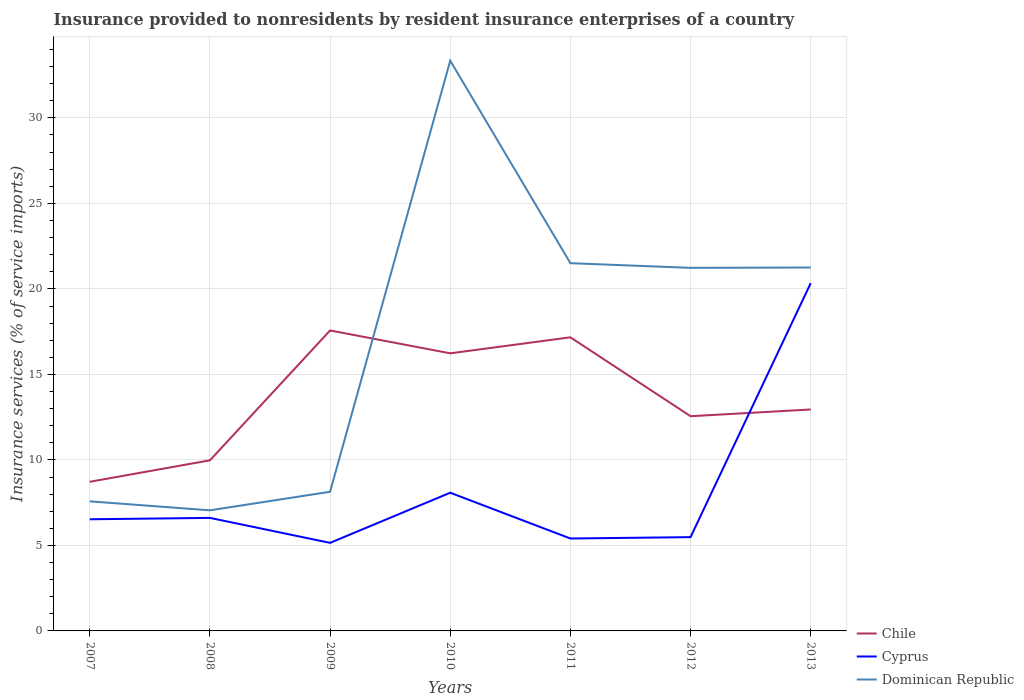How many different coloured lines are there?
Provide a short and direct response. 3. Does the line corresponding to Chile intersect with the line corresponding to Cyprus?
Ensure brevity in your answer.  Yes. Is the number of lines equal to the number of legend labels?
Offer a very short reply. Yes. Across all years, what is the maximum insurance provided to nonresidents in Dominican Republic?
Make the answer very short. 7.05. In which year was the insurance provided to nonresidents in Chile maximum?
Keep it short and to the point. 2007. What is the total insurance provided to nonresidents in Chile in the graph?
Ensure brevity in your answer.  -1.25. What is the difference between the highest and the second highest insurance provided to nonresidents in Chile?
Your answer should be compact. 8.85. Is the insurance provided to nonresidents in Chile strictly greater than the insurance provided to nonresidents in Cyprus over the years?
Provide a succinct answer. No. How many lines are there?
Make the answer very short. 3. Does the graph contain any zero values?
Provide a short and direct response. No. Does the graph contain grids?
Make the answer very short. Yes. What is the title of the graph?
Your response must be concise. Insurance provided to nonresidents by resident insurance enterprises of a country. Does "Burkina Faso" appear as one of the legend labels in the graph?
Ensure brevity in your answer.  No. What is the label or title of the Y-axis?
Give a very brief answer. Insurance services (% of service imports). What is the Insurance services (% of service imports) in Chile in 2007?
Give a very brief answer. 8.72. What is the Insurance services (% of service imports) in Cyprus in 2007?
Your answer should be compact. 6.53. What is the Insurance services (% of service imports) of Dominican Republic in 2007?
Ensure brevity in your answer.  7.58. What is the Insurance services (% of service imports) of Chile in 2008?
Provide a succinct answer. 9.98. What is the Insurance services (% of service imports) of Cyprus in 2008?
Provide a short and direct response. 6.61. What is the Insurance services (% of service imports) of Dominican Republic in 2008?
Make the answer very short. 7.05. What is the Insurance services (% of service imports) in Chile in 2009?
Your response must be concise. 17.57. What is the Insurance services (% of service imports) in Cyprus in 2009?
Offer a very short reply. 5.15. What is the Insurance services (% of service imports) in Dominican Republic in 2009?
Provide a short and direct response. 8.14. What is the Insurance services (% of service imports) in Chile in 2010?
Ensure brevity in your answer.  16.23. What is the Insurance services (% of service imports) of Cyprus in 2010?
Your response must be concise. 8.08. What is the Insurance services (% of service imports) of Dominican Republic in 2010?
Keep it short and to the point. 33.35. What is the Insurance services (% of service imports) of Chile in 2011?
Give a very brief answer. 17.17. What is the Insurance services (% of service imports) of Cyprus in 2011?
Provide a succinct answer. 5.4. What is the Insurance services (% of service imports) of Dominican Republic in 2011?
Make the answer very short. 21.5. What is the Insurance services (% of service imports) of Chile in 2012?
Keep it short and to the point. 12.56. What is the Insurance services (% of service imports) in Cyprus in 2012?
Give a very brief answer. 5.48. What is the Insurance services (% of service imports) in Dominican Republic in 2012?
Give a very brief answer. 21.23. What is the Insurance services (% of service imports) of Chile in 2013?
Your answer should be compact. 12.95. What is the Insurance services (% of service imports) of Cyprus in 2013?
Ensure brevity in your answer.  20.33. What is the Insurance services (% of service imports) in Dominican Republic in 2013?
Provide a succinct answer. 21.25. Across all years, what is the maximum Insurance services (% of service imports) in Chile?
Make the answer very short. 17.57. Across all years, what is the maximum Insurance services (% of service imports) in Cyprus?
Your response must be concise. 20.33. Across all years, what is the maximum Insurance services (% of service imports) in Dominican Republic?
Offer a very short reply. 33.35. Across all years, what is the minimum Insurance services (% of service imports) of Chile?
Your response must be concise. 8.72. Across all years, what is the minimum Insurance services (% of service imports) in Cyprus?
Make the answer very short. 5.15. Across all years, what is the minimum Insurance services (% of service imports) in Dominican Republic?
Your answer should be compact. 7.05. What is the total Insurance services (% of service imports) of Chile in the graph?
Your answer should be very brief. 95.17. What is the total Insurance services (% of service imports) in Cyprus in the graph?
Ensure brevity in your answer.  57.59. What is the total Insurance services (% of service imports) of Dominican Republic in the graph?
Give a very brief answer. 120.1. What is the difference between the Insurance services (% of service imports) of Chile in 2007 and that in 2008?
Provide a short and direct response. -1.25. What is the difference between the Insurance services (% of service imports) of Cyprus in 2007 and that in 2008?
Give a very brief answer. -0.08. What is the difference between the Insurance services (% of service imports) in Dominican Republic in 2007 and that in 2008?
Offer a very short reply. 0.52. What is the difference between the Insurance services (% of service imports) in Chile in 2007 and that in 2009?
Offer a very short reply. -8.85. What is the difference between the Insurance services (% of service imports) in Cyprus in 2007 and that in 2009?
Your response must be concise. 1.38. What is the difference between the Insurance services (% of service imports) of Dominican Republic in 2007 and that in 2009?
Your answer should be very brief. -0.56. What is the difference between the Insurance services (% of service imports) of Chile in 2007 and that in 2010?
Give a very brief answer. -7.51. What is the difference between the Insurance services (% of service imports) of Cyprus in 2007 and that in 2010?
Offer a terse response. -1.55. What is the difference between the Insurance services (% of service imports) of Dominican Republic in 2007 and that in 2010?
Offer a very short reply. -25.77. What is the difference between the Insurance services (% of service imports) of Chile in 2007 and that in 2011?
Your answer should be compact. -8.45. What is the difference between the Insurance services (% of service imports) of Cyprus in 2007 and that in 2011?
Provide a short and direct response. 1.12. What is the difference between the Insurance services (% of service imports) in Dominican Republic in 2007 and that in 2011?
Offer a terse response. -13.93. What is the difference between the Insurance services (% of service imports) in Chile in 2007 and that in 2012?
Provide a short and direct response. -3.83. What is the difference between the Insurance services (% of service imports) in Cyprus in 2007 and that in 2012?
Offer a very short reply. 1.04. What is the difference between the Insurance services (% of service imports) in Dominican Republic in 2007 and that in 2012?
Make the answer very short. -13.65. What is the difference between the Insurance services (% of service imports) of Chile in 2007 and that in 2013?
Your answer should be compact. -4.23. What is the difference between the Insurance services (% of service imports) in Cyprus in 2007 and that in 2013?
Keep it short and to the point. -13.81. What is the difference between the Insurance services (% of service imports) in Dominican Republic in 2007 and that in 2013?
Provide a short and direct response. -13.67. What is the difference between the Insurance services (% of service imports) of Chile in 2008 and that in 2009?
Offer a very short reply. -7.59. What is the difference between the Insurance services (% of service imports) of Cyprus in 2008 and that in 2009?
Keep it short and to the point. 1.46. What is the difference between the Insurance services (% of service imports) in Dominican Republic in 2008 and that in 2009?
Your response must be concise. -1.08. What is the difference between the Insurance services (% of service imports) in Chile in 2008 and that in 2010?
Ensure brevity in your answer.  -6.26. What is the difference between the Insurance services (% of service imports) in Cyprus in 2008 and that in 2010?
Make the answer very short. -1.47. What is the difference between the Insurance services (% of service imports) in Dominican Republic in 2008 and that in 2010?
Make the answer very short. -26.29. What is the difference between the Insurance services (% of service imports) in Chile in 2008 and that in 2011?
Offer a terse response. -7.19. What is the difference between the Insurance services (% of service imports) of Cyprus in 2008 and that in 2011?
Your answer should be compact. 1.21. What is the difference between the Insurance services (% of service imports) of Dominican Republic in 2008 and that in 2011?
Offer a very short reply. -14.45. What is the difference between the Insurance services (% of service imports) of Chile in 2008 and that in 2012?
Offer a very short reply. -2.58. What is the difference between the Insurance services (% of service imports) in Cyprus in 2008 and that in 2012?
Offer a very short reply. 1.13. What is the difference between the Insurance services (% of service imports) in Dominican Republic in 2008 and that in 2012?
Offer a very short reply. -14.18. What is the difference between the Insurance services (% of service imports) of Chile in 2008 and that in 2013?
Ensure brevity in your answer.  -2.97. What is the difference between the Insurance services (% of service imports) in Cyprus in 2008 and that in 2013?
Provide a short and direct response. -13.72. What is the difference between the Insurance services (% of service imports) of Dominican Republic in 2008 and that in 2013?
Ensure brevity in your answer.  -14.2. What is the difference between the Insurance services (% of service imports) in Chile in 2009 and that in 2010?
Your answer should be very brief. 1.34. What is the difference between the Insurance services (% of service imports) in Cyprus in 2009 and that in 2010?
Provide a succinct answer. -2.93. What is the difference between the Insurance services (% of service imports) of Dominican Republic in 2009 and that in 2010?
Ensure brevity in your answer.  -25.21. What is the difference between the Insurance services (% of service imports) in Chile in 2009 and that in 2011?
Your answer should be very brief. 0.4. What is the difference between the Insurance services (% of service imports) of Cyprus in 2009 and that in 2011?
Your answer should be compact. -0.26. What is the difference between the Insurance services (% of service imports) of Dominican Republic in 2009 and that in 2011?
Your response must be concise. -13.37. What is the difference between the Insurance services (% of service imports) in Chile in 2009 and that in 2012?
Provide a short and direct response. 5.01. What is the difference between the Insurance services (% of service imports) of Cyprus in 2009 and that in 2012?
Provide a short and direct response. -0.33. What is the difference between the Insurance services (% of service imports) in Dominican Republic in 2009 and that in 2012?
Provide a succinct answer. -13.1. What is the difference between the Insurance services (% of service imports) in Chile in 2009 and that in 2013?
Ensure brevity in your answer.  4.62. What is the difference between the Insurance services (% of service imports) in Cyprus in 2009 and that in 2013?
Make the answer very short. -15.19. What is the difference between the Insurance services (% of service imports) of Dominican Republic in 2009 and that in 2013?
Your answer should be very brief. -13.11. What is the difference between the Insurance services (% of service imports) of Chile in 2010 and that in 2011?
Your answer should be very brief. -0.94. What is the difference between the Insurance services (% of service imports) of Cyprus in 2010 and that in 2011?
Provide a succinct answer. 2.68. What is the difference between the Insurance services (% of service imports) in Dominican Republic in 2010 and that in 2011?
Provide a short and direct response. 11.84. What is the difference between the Insurance services (% of service imports) in Chile in 2010 and that in 2012?
Keep it short and to the point. 3.68. What is the difference between the Insurance services (% of service imports) in Cyprus in 2010 and that in 2012?
Provide a short and direct response. 2.6. What is the difference between the Insurance services (% of service imports) in Dominican Republic in 2010 and that in 2012?
Offer a terse response. 12.11. What is the difference between the Insurance services (% of service imports) in Chile in 2010 and that in 2013?
Ensure brevity in your answer.  3.28. What is the difference between the Insurance services (% of service imports) in Cyprus in 2010 and that in 2013?
Offer a terse response. -12.25. What is the difference between the Insurance services (% of service imports) of Dominican Republic in 2010 and that in 2013?
Your answer should be compact. 12.09. What is the difference between the Insurance services (% of service imports) of Chile in 2011 and that in 2012?
Provide a succinct answer. 4.61. What is the difference between the Insurance services (% of service imports) in Cyprus in 2011 and that in 2012?
Offer a very short reply. -0.08. What is the difference between the Insurance services (% of service imports) in Dominican Republic in 2011 and that in 2012?
Your answer should be very brief. 0.27. What is the difference between the Insurance services (% of service imports) in Chile in 2011 and that in 2013?
Provide a succinct answer. 4.22. What is the difference between the Insurance services (% of service imports) in Cyprus in 2011 and that in 2013?
Keep it short and to the point. -14.93. What is the difference between the Insurance services (% of service imports) in Dominican Republic in 2011 and that in 2013?
Provide a short and direct response. 0.25. What is the difference between the Insurance services (% of service imports) of Chile in 2012 and that in 2013?
Your response must be concise. -0.39. What is the difference between the Insurance services (% of service imports) in Cyprus in 2012 and that in 2013?
Provide a succinct answer. -14.85. What is the difference between the Insurance services (% of service imports) in Dominican Republic in 2012 and that in 2013?
Keep it short and to the point. -0.02. What is the difference between the Insurance services (% of service imports) of Chile in 2007 and the Insurance services (% of service imports) of Cyprus in 2008?
Your answer should be compact. 2.11. What is the difference between the Insurance services (% of service imports) of Chile in 2007 and the Insurance services (% of service imports) of Dominican Republic in 2008?
Give a very brief answer. 1.67. What is the difference between the Insurance services (% of service imports) in Cyprus in 2007 and the Insurance services (% of service imports) in Dominican Republic in 2008?
Your answer should be compact. -0.52. What is the difference between the Insurance services (% of service imports) in Chile in 2007 and the Insurance services (% of service imports) in Cyprus in 2009?
Ensure brevity in your answer.  3.57. What is the difference between the Insurance services (% of service imports) in Chile in 2007 and the Insurance services (% of service imports) in Dominican Republic in 2009?
Provide a short and direct response. 0.58. What is the difference between the Insurance services (% of service imports) of Cyprus in 2007 and the Insurance services (% of service imports) of Dominican Republic in 2009?
Ensure brevity in your answer.  -1.61. What is the difference between the Insurance services (% of service imports) in Chile in 2007 and the Insurance services (% of service imports) in Cyprus in 2010?
Your answer should be very brief. 0.64. What is the difference between the Insurance services (% of service imports) of Chile in 2007 and the Insurance services (% of service imports) of Dominican Republic in 2010?
Give a very brief answer. -24.62. What is the difference between the Insurance services (% of service imports) of Cyprus in 2007 and the Insurance services (% of service imports) of Dominican Republic in 2010?
Offer a terse response. -26.82. What is the difference between the Insurance services (% of service imports) of Chile in 2007 and the Insurance services (% of service imports) of Cyprus in 2011?
Offer a terse response. 3.32. What is the difference between the Insurance services (% of service imports) in Chile in 2007 and the Insurance services (% of service imports) in Dominican Republic in 2011?
Provide a succinct answer. -12.78. What is the difference between the Insurance services (% of service imports) of Cyprus in 2007 and the Insurance services (% of service imports) of Dominican Republic in 2011?
Provide a succinct answer. -14.98. What is the difference between the Insurance services (% of service imports) of Chile in 2007 and the Insurance services (% of service imports) of Cyprus in 2012?
Keep it short and to the point. 3.24. What is the difference between the Insurance services (% of service imports) of Chile in 2007 and the Insurance services (% of service imports) of Dominican Republic in 2012?
Ensure brevity in your answer.  -12.51. What is the difference between the Insurance services (% of service imports) in Cyprus in 2007 and the Insurance services (% of service imports) in Dominican Republic in 2012?
Make the answer very short. -14.7. What is the difference between the Insurance services (% of service imports) in Chile in 2007 and the Insurance services (% of service imports) in Cyprus in 2013?
Make the answer very short. -11.61. What is the difference between the Insurance services (% of service imports) of Chile in 2007 and the Insurance services (% of service imports) of Dominican Republic in 2013?
Offer a very short reply. -12.53. What is the difference between the Insurance services (% of service imports) of Cyprus in 2007 and the Insurance services (% of service imports) of Dominican Republic in 2013?
Your answer should be very brief. -14.72. What is the difference between the Insurance services (% of service imports) of Chile in 2008 and the Insurance services (% of service imports) of Cyprus in 2009?
Give a very brief answer. 4.83. What is the difference between the Insurance services (% of service imports) in Chile in 2008 and the Insurance services (% of service imports) in Dominican Republic in 2009?
Offer a terse response. 1.84. What is the difference between the Insurance services (% of service imports) in Cyprus in 2008 and the Insurance services (% of service imports) in Dominican Republic in 2009?
Your response must be concise. -1.53. What is the difference between the Insurance services (% of service imports) of Chile in 2008 and the Insurance services (% of service imports) of Cyprus in 2010?
Keep it short and to the point. 1.89. What is the difference between the Insurance services (% of service imports) in Chile in 2008 and the Insurance services (% of service imports) in Dominican Republic in 2010?
Ensure brevity in your answer.  -23.37. What is the difference between the Insurance services (% of service imports) in Cyprus in 2008 and the Insurance services (% of service imports) in Dominican Republic in 2010?
Make the answer very short. -26.74. What is the difference between the Insurance services (% of service imports) of Chile in 2008 and the Insurance services (% of service imports) of Cyprus in 2011?
Make the answer very short. 4.57. What is the difference between the Insurance services (% of service imports) of Chile in 2008 and the Insurance services (% of service imports) of Dominican Republic in 2011?
Give a very brief answer. -11.53. What is the difference between the Insurance services (% of service imports) of Cyprus in 2008 and the Insurance services (% of service imports) of Dominican Republic in 2011?
Ensure brevity in your answer.  -14.89. What is the difference between the Insurance services (% of service imports) of Chile in 2008 and the Insurance services (% of service imports) of Cyprus in 2012?
Offer a very short reply. 4.49. What is the difference between the Insurance services (% of service imports) of Chile in 2008 and the Insurance services (% of service imports) of Dominican Republic in 2012?
Keep it short and to the point. -11.26. What is the difference between the Insurance services (% of service imports) in Cyprus in 2008 and the Insurance services (% of service imports) in Dominican Republic in 2012?
Make the answer very short. -14.62. What is the difference between the Insurance services (% of service imports) in Chile in 2008 and the Insurance services (% of service imports) in Cyprus in 2013?
Provide a short and direct response. -10.36. What is the difference between the Insurance services (% of service imports) of Chile in 2008 and the Insurance services (% of service imports) of Dominican Republic in 2013?
Provide a short and direct response. -11.28. What is the difference between the Insurance services (% of service imports) in Cyprus in 2008 and the Insurance services (% of service imports) in Dominican Republic in 2013?
Provide a succinct answer. -14.64. What is the difference between the Insurance services (% of service imports) of Chile in 2009 and the Insurance services (% of service imports) of Cyprus in 2010?
Offer a terse response. 9.49. What is the difference between the Insurance services (% of service imports) in Chile in 2009 and the Insurance services (% of service imports) in Dominican Republic in 2010?
Provide a short and direct response. -15.78. What is the difference between the Insurance services (% of service imports) in Cyprus in 2009 and the Insurance services (% of service imports) in Dominican Republic in 2010?
Keep it short and to the point. -28.2. What is the difference between the Insurance services (% of service imports) in Chile in 2009 and the Insurance services (% of service imports) in Cyprus in 2011?
Provide a short and direct response. 12.17. What is the difference between the Insurance services (% of service imports) in Chile in 2009 and the Insurance services (% of service imports) in Dominican Republic in 2011?
Give a very brief answer. -3.93. What is the difference between the Insurance services (% of service imports) of Cyprus in 2009 and the Insurance services (% of service imports) of Dominican Republic in 2011?
Your answer should be very brief. -16.35. What is the difference between the Insurance services (% of service imports) of Chile in 2009 and the Insurance services (% of service imports) of Cyprus in 2012?
Ensure brevity in your answer.  12.09. What is the difference between the Insurance services (% of service imports) in Chile in 2009 and the Insurance services (% of service imports) in Dominican Republic in 2012?
Ensure brevity in your answer.  -3.66. What is the difference between the Insurance services (% of service imports) of Cyprus in 2009 and the Insurance services (% of service imports) of Dominican Republic in 2012?
Your answer should be compact. -16.08. What is the difference between the Insurance services (% of service imports) of Chile in 2009 and the Insurance services (% of service imports) of Cyprus in 2013?
Your answer should be compact. -2.76. What is the difference between the Insurance services (% of service imports) in Chile in 2009 and the Insurance services (% of service imports) in Dominican Republic in 2013?
Your response must be concise. -3.68. What is the difference between the Insurance services (% of service imports) in Cyprus in 2009 and the Insurance services (% of service imports) in Dominican Republic in 2013?
Your answer should be compact. -16.1. What is the difference between the Insurance services (% of service imports) of Chile in 2010 and the Insurance services (% of service imports) of Cyprus in 2011?
Give a very brief answer. 10.83. What is the difference between the Insurance services (% of service imports) in Chile in 2010 and the Insurance services (% of service imports) in Dominican Republic in 2011?
Provide a succinct answer. -5.27. What is the difference between the Insurance services (% of service imports) of Cyprus in 2010 and the Insurance services (% of service imports) of Dominican Republic in 2011?
Give a very brief answer. -13.42. What is the difference between the Insurance services (% of service imports) in Chile in 2010 and the Insurance services (% of service imports) in Cyprus in 2012?
Make the answer very short. 10.75. What is the difference between the Insurance services (% of service imports) of Chile in 2010 and the Insurance services (% of service imports) of Dominican Republic in 2012?
Offer a terse response. -5. What is the difference between the Insurance services (% of service imports) of Cyprus in 2010 and the Insurance services (% of service imports) of Dominican Republic in 2012?
Make the answer very short. -13.15. What is the difference between the Insurance services (% of service imports) in Chile in 2010 and the Insurance services (% of service imports) in Cyprus in 2013?
Offer a terse response. -4.1. What is the difference between the Insurance services (% of service imports) in Chile in 2010 and the Insurance services (% of service imports) in Dominican Republic in 2013?
Your answer should be very brief. -5.02. What is the difference between the Insurance services (% of service imports) in Cyprus in 2010 and the Insurance services (% of service imports) in Dominican Republic in 2013?
Provide a succinct answer. -13.17. What is the difference between the Insurance services (% of service imports) in Chile in 2011 and the Insurance services (% of service imports) in Cyprus in 2012?
Your response must be concise. 11.69. What is the difference between the Insurance services (% of service imports) in Chile in 2011 and the Insurance services (% of service imports) in Dominican Republic in 2012?
Keep it short and to the point. -4.06. What is the difference between the Insurance services (% of service imports) in Cyprus in 2011 and the Insurance services (% of service imports) in Dominican Republic in 2012?
Ensure brevity in your answer.  -15.83. What is the difference between the Insurance services (% of service imports) of Chile in 2011 and the Insurance services (% of service imports) of Cyprus in 2013?
Your answer should be compact. -3.17. What is the difference between the Insurance services (% of service imports) of Chile in 2011 and the Insurance services (% of service imports) of Dominican Republic in 2013?
Give a very brief answer. -4.08. What is the difference between the Insurance services (% of service imports) in Cyprus in 2011 and the Insurance services (% of service imports) in Dominican Republic in 2013?
Your answer should be compact. -15.85. What is the difference between the Insurance services (% of service imports) of Chile in 2012 and the Insurance services (% of service imports) of Cyprus in 2013?
Keep it short and to the point. -7.78. What is the difference between the Insurance services (% of service imports) of Chile in 2012 and the Insurance services (% of service imports) of Dominican Republic in 2013?
Provide a succinct answer. -8.7. What is the difference between the Insurance services (% of service imports) in Cyprus in 2012 and the Insurance services (% of service imports) in Dominican Republic in 2013?
Provide a short and direct response. -15.77. What is the average Insurance services (% of service imports) in Chile per year?
Offer a terse response. 13.6. What is the average Insurance services (% of service imports) in Cyprus per year?
Your answer should be very brief. 8.23. What is the average Insurance services (% of service imports) in Dominican Republic per year?
Your response must be concise. 17.16. In the year 2007, what is the difference between the Insurance services (% of service imports) of Chile and Insurance services (% of service imports) of Cyprus?
Your answer should be compact. 2.19. In the year 2007, what is the difference between the Insurance services (% of service imports) in Chile and Insurance services (% of service imports) in Dominican Republic?
Give a very brief answer. 1.14. In the year 2007, what is the difference between the Insurance services (% of service imports) in Cyprus and Insurance services (% of service imports) in Dominican Republic?
Offer a terse response. -1.05. In the year 2008, what is the difference between the Insurance services (% of service imports) in Chile and Insurance services (% of service imports) in Cyprus?
Your response must be concise. 3.37. In the year 2008, what is the difference between the Insurance services (% of service imports) of Chile and Insurance services (% of service imports) of Dominican Republic?
Offer a terse response. 2.92. In the year 2008, what is the difference between the Insurance services (% of service imports) in Cyprus and Insurance services (% of service imports) in Dominican Republic?
Keep it short and to the point. -0.44. In the year 2009, what is the difference between the Insurance services (% of service imports) in Chile and Insurance services (% of service imports) in Cyprus?
Give a very brief answer. 12.42. In the year 2009, what is the difference between the Insurance services (% of service imports) in Chile and Insurance services (% of service imports) in Dominican Republic?
Keep it short and to the point. 9.43. In the year 2009, what is the difference between the Insurance services (% of service imports) in Cyprus and Insurance services (% of service imports) in Dominican Republic?
Your answer should be compact. -2.99. In the year 2010, what is the difference between the Insurance services (% of service imports) of Chile and Insurance services (% of service imports) of Cyprus?
Offer a terse response. 8.15. In the year 2010, what is the difference between the Insurance services (% of service imports) of Chile and Insurance services (% of service imports) of Dominican Republic?
Your answer should be very brief. -17.11. In the year 2010, what is the difference between the Insurance services (% of service imports) in Cyprus and Insurance services (% of service imports) in Dominican Republic?
Offer a terse response. -25.26. In the year 2011, what is the difference between the Insurance services (% of service imports) of Chile and Insurance services (% of service imports) of Cyprus?
Your answer should be compact. 11.76. In the year 2011, what is the difference between the Insurance services (% of service imports) in Chile and Insurance services (% of service imports) in Dominican Republic?
Your answer should be compact. -4.33. In the year 2011, what is the difference between the Insurance services (% of service imports) in Cyprus and Insurance services (% of service imports) in Dominican Republic?
Provide a short and direct response. -16.1. In the year 2012, what is the difference between the Insurance services (% of service imports) of Chile and Insurance services (% of service imports) of Cyprus?
Provide a succinct answer. 7.07. In the year 2012, what is the difference between the Insurance services (% of service imports) in Chile and Insurance services (% of service imports) in Dominican Republic?
Offer a very short reply. -8.68. In the year 2012, what is the difference between the Insurance services (% of service imports) in Cyprus and Insurance services (% of service imports) in Dominican Republic?
Offer a very short reply. -15.75. In the year 2013, what is the difference between the Insurance services (% of service imports) of Chile and Insurance services (% of service imports) of Cyprus?
Your answer should be very brief. -7.38. In the year 2013, what is the difference between the Insurance services (% of service imports) in Chile and Insurance services (% of service imports) in Dominican Republic?
Your answer should be very brief. -8.3. In the year 2013, what is the difference between the Insurance services (% of service imports) of Cyprus and Insurance services (% of service imports) of Dominican Republic?
Your answer should be compact. -0.92. What is the ratio of the Insurance services (% of service imports) in Chile in 2007 to that in 2008?
Keep it short and to the point. 0.87. What is the ratio of the Insurance services (% of service imports) in Dominican Republic in 2007 to that in 2008?
Keep it short and to the point. 1.07. What is the ratio of the Insurance services (% of service imports) in Chile in 2007 to that in 2009?
Provide a short and direct response. 0.5. What is the ratio of the Insurance services (% of service imports) in Cyprus in 2007 to that in 2009?
Provide a succinct answer. 1.27. What is the ratio of the Insurance services (% of service imports) of Dominican Republic in 2007 to that in 2009?
Make the answer very short. 0.93. What is the ratio of the Insurance services (% of service imports) of Chile in 2007 to that in 2010?
Your response must be concise. 0.54. What is the ratio of the Insurance services (% of service imports) in Cyprus in 2007 to that in 2010?
Keep it short and to the point. 0.81. What is the ratio of the Insurance services (% of service imports) of Dominican Republic in 2007 to that in 2010?
Your response must be concise. 0.23. What is the ratio of the Insurance services (% of service imports) of Chile in 2007 to that in 2011?
Give a very brief answer. 0.51. What is the ratio of the Insurance services (% of service imports) of Cyprus in 2007 to that in 2011?
Your answer should be compact. 1.21. What is the ratio of the Insurance services (% of service imports) of Dominican Republic in 2007 to that in 2011?
Provide a succinct answer. 0.35. What is the ratio of the Insurance services (% of service imports) of Chile in 2007 to that in 2012?
Your response must be concise. 0.69. What is the ratio of the Insurance services (% of service imports) in Cyprus in 2007 to that in 2012?
Offer a very short reply. 1.19. What is the ratio of the Insurance services (% of service imports) of Dominican Republic in 2007 to that in 2012?
Ensure brevity in your answer.  0.36. What is the ratio of the Insurance services (% of service imports) of Chile in 2007 to that in 2013?
Your response must be concise. 0.67. What is the ratio of the Insurance services (% of service imports) in Cyprus in 2007 to that in 2013?
Offer a very short reply. 0.32. What is the ratio of the Insurance services (% of service imports) in Dominican Republic in 2007 to that in 2013?
Your answer should be very brief. 0.36. What is the ratio of the Insurance services (% of service imports) in Chile in 2008 to that in 2009?
Keep it short and to the point. 0.57. What is the ratio of the Insurance services (% of service imports) of Cyprus in 2008 to that in 2009?
Make the answer very short. 1.28. What is the ratio of the Insurance services (% of service imports) in Dominican Republic in 2008 to that in 2009?
Offer a terse response. 0.87. What is the ratio of the Insurance services (% of service imports) of Chile in 2008 to that in 2010?
Provide a succinct answer. 0.61. What is the ratio of the Insurance services (% of service imports) of Cyprus in 2008 to that in 2010?
Provide a succinct answer. 0.82. What is the ratio of the Insurance services (% of service imports) in Dominican Republic in 2008 to that in 2010?
Give a very brief answer. 0.21. What is the ratio of the Insurance services (% of service imports) of Chile in 2008 to that in 2011?
Make the answer very short. 0.58. What is the ratio of the Insurance services (% of service imports) of Cyprus in 2008 to that in 2011?
Make the answer very short. 1.22. What is the ratio of the Insurance services (% of service imports) of Dominican Republic in 2008 to that in 2011?
Offer a very short reply. 0.33. What is the ratio of the Insurance services (% of service imports) of Chile in 2008 to that in 2012?
Your answer should be compact. 0.79. What is the ratio of the Insurance services (% of service imports) in Cyprus in 2008 to that in 2012?
Keep it short and to the point. 1.21. What is the ratio of the Insurance services (% of service imports) of Dominican Republic in 2008 to that in 2012?
Ensure brevity in your answer.  0.33. What is the ratio of the Insurance services (% of service imports) in Chile in 2008 to that in 2013?
Your answer should be very brief. 0.77. What is the ratio of the Insurance services (% of service imports) of Cyprus in 2008 to that in 2013?
Ensure brevity in your answer.  0.33. What is the ratio of the Insurance services (% of service imports) in Dominican Republic in 2008 to that in 2013?
Provide a short and direct response. 0.33. What is the ratio of the Insurance services (% of service imports) in Chile in 2009 to that in 2010?
Your response must be concise. 1.08. What is the ratio of the Insurance services (% of service imports) of Cyprus in 2009 to that in 2010?
Your response must be concise. 0.64. What is the ratio of the Insurance services (% of service imports) in Dominican Republic in 2009 to that in 2010?
Ensure brevity in your answer.  0.24. What is the ratio of the Insurance services (% of service imports) in Chile in 2009 to that in 2011?
Keep it short and to the point. 1.02. What is the ratio of the Insurance services (% of service imports) in Cyprus in 2009 to that in 2011?
Make the answer very short. 0.95. What is the ratio of the Insurance services (% of service imports) in Dominican Republic in 2009 to that in 2011?
Give a very brief answer. 0.38. What is the ratio of the Insurance services (% of service imports) of Chile in 2009 to that in 2012?
Provide a succinct answer. 1.4. What is the ratio of the Insurance services (% of service imports) of Cyprus in 2009 to that in 2012?
Your answer should be compact. 0.94. What is the ratio of the Insurance services (% of service imports) of Dominican Republic in 2009 to that in 2012?
Give a very brief answer. 0.38. What is the ratio of the Insurance services (% of service imports) of Chile in 2009 to that in 2013?
Ensure brevity in your answer.  1.36. What is the ratio of the Insurance services (% of service imports) in Cyprus in 2009 to that in 2013?
Provide a succinct answer. 0.25. What is the ratio of the Insurance services (% of service imports) of Dominican Republic in 2009 to that in 2013?
Provide a succinct answer. 0.38. What is the ratio of the Insurance services (% of service imports) in Chile in 2010 to that in 2011?
Make the answer very short. 0.95. What is the ratio of the Insurance services (% of service imports) of Cyprus in 2010 to that in 2011?
Provide a succinct answer. 1.5. What is the ratio of the Insurance services (% of service imports) of Dominican Republic in 2010 to that in 2011?
Offer a very short reply. 1.55. What is the ratio of the Insurance services (% of service imports) of Chile in 2010 to that in 2012?
Your response must be concise. 1.29. What is the ratio of the Insurance services (% of service imports) in Cyprus in 2010 to that in 2012?
Your response must be concise. 1.47. What is the ratio of the Insurance services (% of service imports) in Dominican Republic in 2010 to that in 2012?
Offer a terse response. 1.57. What is the ratio of the Insurance services (% of service imports) in Chile in 2010 to that in 2013?
Your answer should be compact. 1.25. What is the ratio of the Insurance services (% of service imports) in Cyprus in 2010 to that in 2013?
Ensure brevity in your answer.  0.4. What is the ratio of the Insurance services (% of service imports) of Dominican Republic in 2010 to that in 2013?
Provide a succinct answer. 1.57. What is the ratio of the Insurance services (% of service imports) in Chile in 2011 to that in 2012?
Your answer should be very brief. 1.37. What is the ratio of the Insurance services (% of service imports) of Cyprus in 2011 to that in 2012?
Offer a very short reply. 0.99. What is the ratio of the Insurance services (% of service imports) of Dominican Republic in 2011 to that in 2012?
Make the answer very short. 1.01. What is the ratio of the Insurance services (% of service imports) of Chile in 2011 to that in 2013?
Offer a terse response. 1.33. What is the ratio of the Insurance services (% of service imports) of Cyprus in 2011 to that in 2013?
Offer a terse response. 0.27. What is the ratio of the Insurance services (% of service imports) in Dominican Republic in 2011 to that in 2013?
Keep it short and to the point. 1.01. What is the ratio of the Insurance services (% of service imports) of Chile in 2012 to that in 2013?
Ensure brevity in your answer.  0.97. What is the ratio of the Insurance services (% of service imports) of Cyprus in 2012 to that in 2013?
Give a very brief answer. 0.27. What is the ratio of the Insurance services (% of service imports) in Dominican Republic in 2012 to that in 2013?
Keep it short and to the point. 1. What is the difference between the highest and the second highest Insurance services (% of service imports) of Chile?
Provide a succinct answer. 0.4. What is the difference between the highest and the second highest Insurance services (% of service imports) in Cyprus?
Your answer should be very brief. 12.25. What is the difference between the highest and the second highest Insurance services (% of service imports) in Dominican Republic?
Provide a short and direct response. 11.84. What is the difference between the highest and the lowest Insurance services (% of service imports) of Chile?
Your response must be concise. 8.85. What is the difference between the highest and the lowest Insurance services (% of service imports) in Cyprus?
Offer a terse response. 15.19. What is the difference between the highest and the lowest Insurance services (% of service imports) in Dominican Republic?
Give a very brief answer. 26.29. 